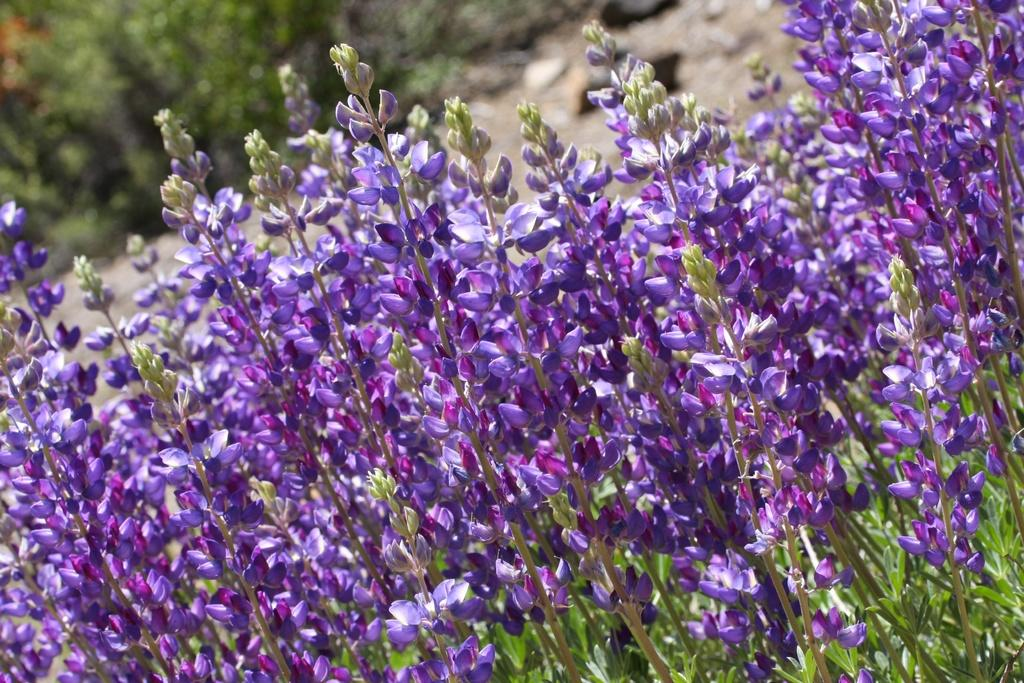What type of plant life is visible in the image? There are stems with flowers and leaves in the image. What can be seen in the background of the image? The background of the image is blurred. What type of cave can be seen in the background of the image? There is no cave present in the image; the background is blurred. 